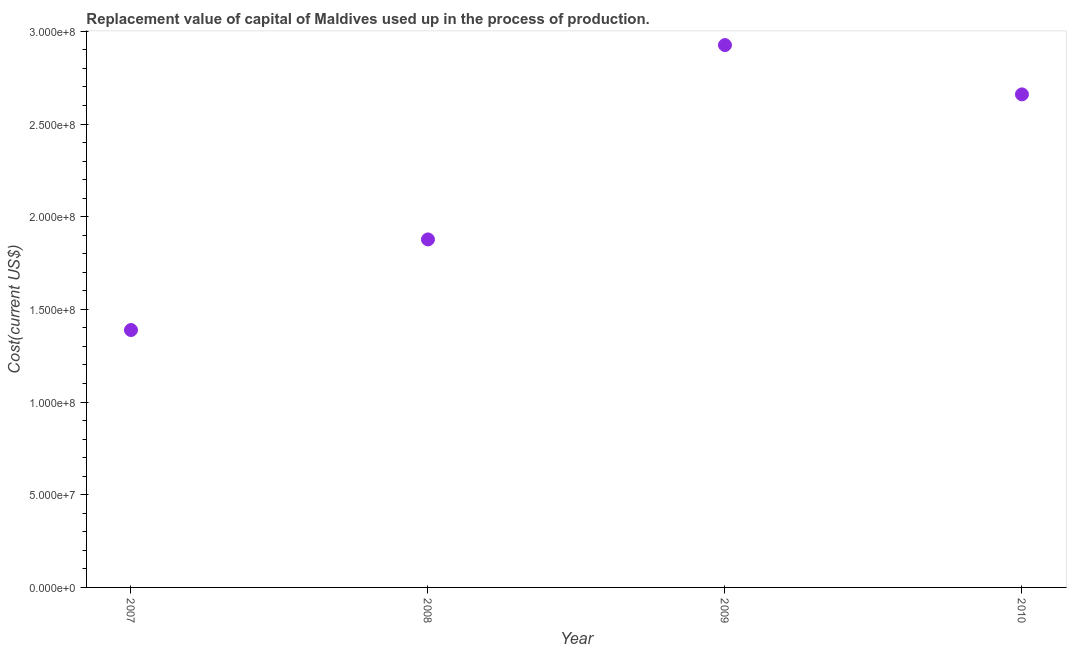What is the consumption of fixed capital in 2009?
Provide a short and direct response. 2.93e+08. Across all years, what is the maximum consumption of fixed capital?
Offer a very short reply. 2.93e+08. Across all years, what is the minimum consumption of fixed capital?
Give a very brief answer. 1.39e+08. In which year was the consumption of fixed capital maximum?
Ensure brevity in your answer.  2009. What is the sum of the consumption of fixed capital?
Provide a short and direct response. 8.85e+08. What is the difference between the consumption of fixed capital in 2008 and 2009?
Your answer should be compact. -1.05e+08. What is the average consumption of fixed capital per year?
Make the answer very short. 2.21e+08. What is the median consumption of fixed capital?
Your answer should be compact. 2.27e+08. In how many years, is the consumption of fixed capital greater than 290000000 US$?
Keep it short and to the point. 1. Do a majority of the years between 2009 and 2007 (inclusive) have consumption of fixed capital greater than 110000000 US$?
Make the answer very short. No. What is the ratio of the consumption of fixed capital in 2009 to that in 2010?
Provide a succinct answer. 1.1. Is the consumption of fixed capital in 2007 less than that in 2010?
Provide a short and direct response. Yes. Is the difference between the consumption of fixed capital in 2009 and 2010 greater than the difference between any two years?
Your response must be concise. No. What is the difference between the highest and the second highest consumption of fixed capital?
Make the answer very short. 2.66e+07. Is the sum of the consumption of fixed capital in 2008 and 2010 greater than the maximum consumption of fixed capital across all years?
Your answer should be compact. Yes. What is the difference between the highest and the lowest consumption of fixed capital?
Your response must be concise. 1.54e+08. In how many years, is the consumption of fixed capital greater than the average consumption of fixed capital taken over all years?
Provide a succinct answer. 2. How many dotlines are there?
Offer a very short reply. 1. Are the values on the major ticks of Y-axis written in scientific E-notation?
Give a very brief answer. Yes. Does the graph contain any zero values?
Offer a very short reply. No. What is the title of the graph?
Give a very brief answer. Replacement value of capital of Maldives used up in the process of production. What is the label or title of the X-axis?
Ensure brevity in your answer.  Year. What is the label or title of the Y-axis?
Your response must be concise. Cost(current US$). What is the Cost(current US$) in 2007?
Your answer should be very brief. 1.39e+08. What is the Cost(current US$) in 2008?
Provide a short and direct response. 1.88e+08. What is the Cost(current US$) in 2009?
Provide a short and direct response. 2.93e+08. What is the Cost(current US$) in 2010?
Offer a terse response. 2.66e+08. What is the difference between the Cost(current US$) in 2007 and 2008?
Ensure brevity in your answer.  -4.89e+07. What is the difference between the Cost(current US$) in 2007 and 2009?
Give a very brief answer. -1.54e+08. What is the difference between the Cost(current US$) in 2007 and 2010?
Make the answer very short. -1.27e+08. What is the difference between the Cost(current US$) in 2008 and 2009?
Your answer should be very brief. -1.05e+08. What is the difference between the Cost(current US$) in 2008 and 2010?
Make the answer very short. -7.83e+07. What is the difference between the Cost(current US$) in 2009 and 2010?
Your answer should be very brief. 2.66e+07. What is the ratio of the Cost(current US$) in 2007 to that in 2008?
Make the answer very short. 0.74. What is the ratio of the Cost(current US$) in 2007 to that in 2009?
Your answer should be compact. 0.47. What is the ratio of the Cost(current US$) in 2007 to that in 2010?
Offer a very short reply. 0.52. What is the ratio of the Cost(current US$) in 2008 to that in 2009?
Provide a succinct answer. 0.64. What is the ratio of the Cost(current US$) in 2008 to that in 2010?
Your response must be concise. 0.71. What is the ratio of the Cost(current US$) in 2009 to that in 2010?
Give a very brief answer. 1.1. 